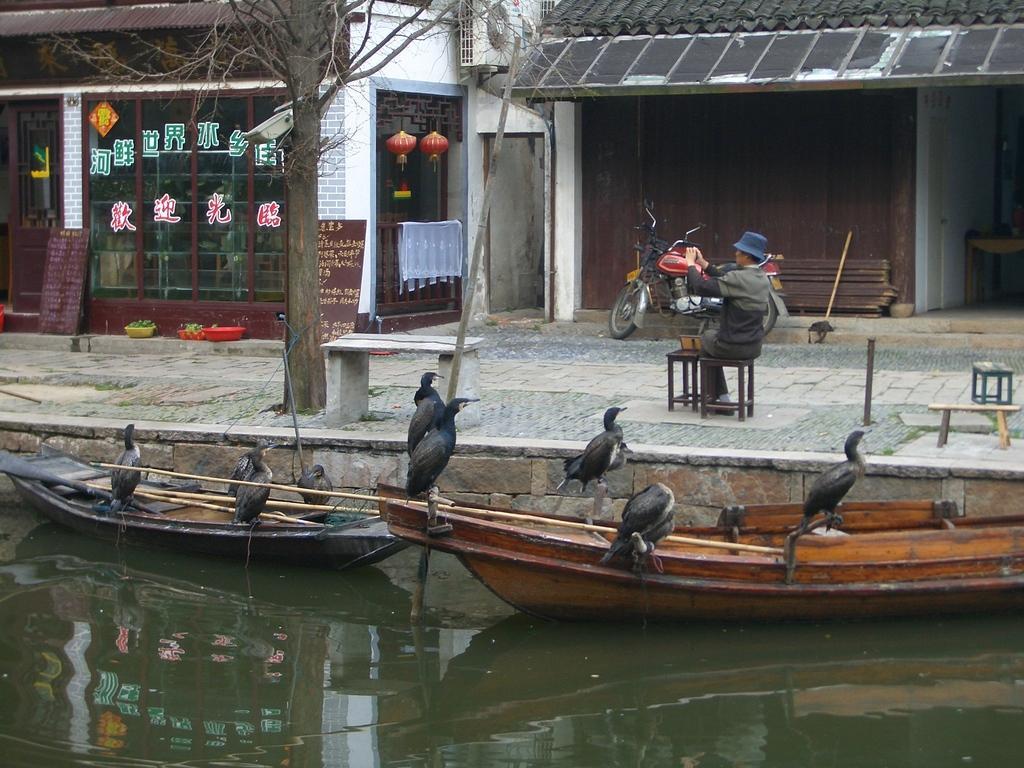In one or two sentences, can you explain what this image depicts? In the picture we can see a part of the water surface with two boats in it, and on the boats we can see some birds are sitting and beside it, we can see the path with a tree and beside it, we can see two small benches and a man sitting on the stool and behind the man we can see two houses with shops and one is closed and one is with glass wall. 